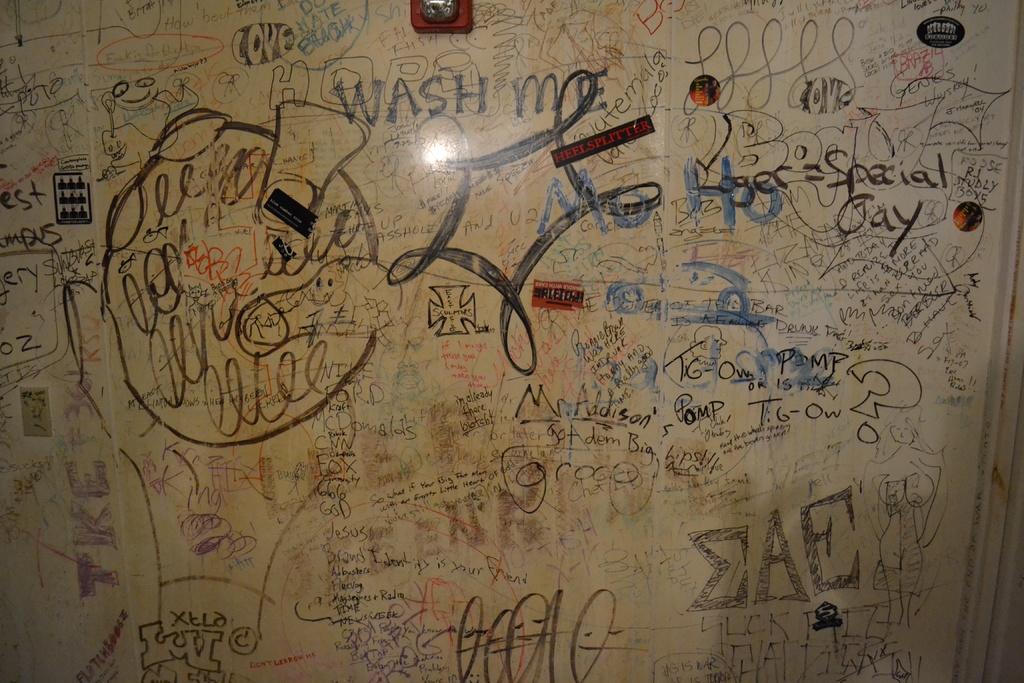What are the 3 capital letters at the bottom right?
Your answer should be very brief. Eae. 